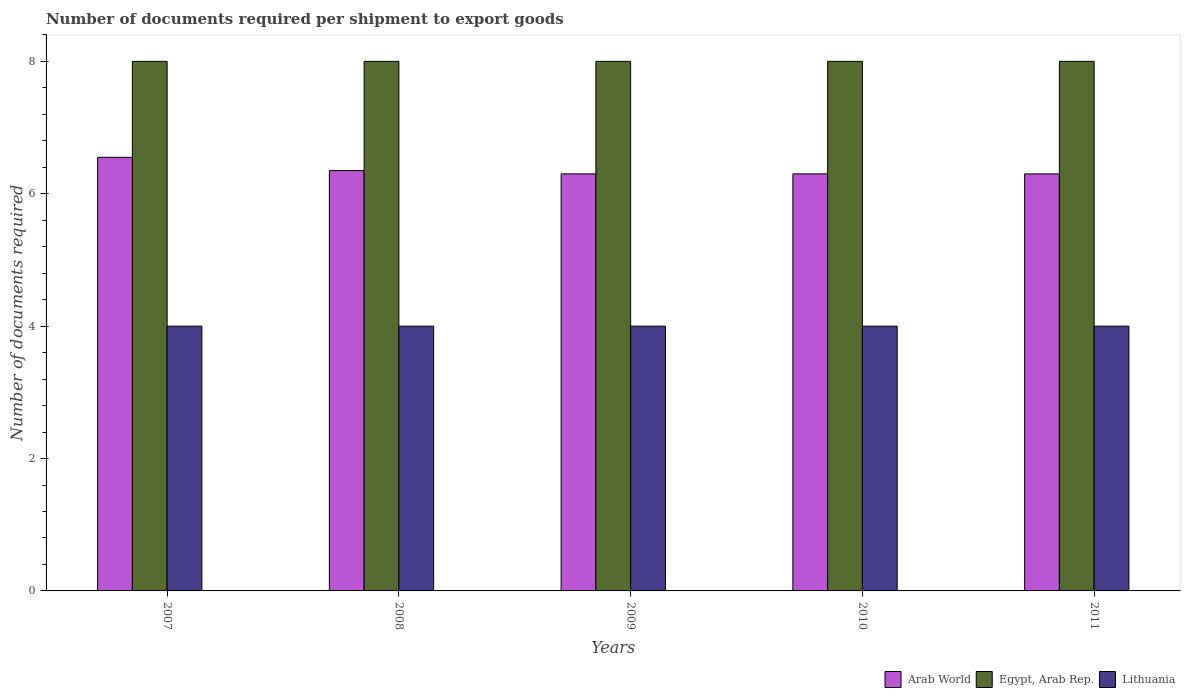How many different coloured bars are there?
Keep it short and to the point. 3. How many groups of bars are there?
Offer a very short reply. 5. Are the number of bars per tick equal to the number of legend labels?
Offer a terse response. Yes. In how many cases, is the number of bars for a given year not equal to the number of legend labels?
Ensure brevity in your answer.  0. Across all years, what is the maximum number of documents required per shipment to export goods in Arab World?
Offer a very short reply. 6.55. Across all years, what is the minimum number of documents required per shipment to export goods in Lithuania?
Provide a succinct answer. 4. What is the total number of documents required per shipment to export goods in Arab World in the graph?
Provide a short and direct response. 31.8. What is the difference between the number of documents required per shipment to export goods in Lithuania in 2007 and the number of documents required per shipment to export goods in Egypt, Arab Rep. in 2010?
Give a very brief answer. -4. What is the average number of documents required per shipment to export goods in Arab World per year?
Provide a succinct answer. 6.36. In the year 2009, what is the difference between the number of documents required per shipment to export goods in Arab World and number of documents required per shipment to export goods in Lithuania?
Offer a terse response. 2.3. Is the difference between the number of documents required per shipment to export goods in Arab World in 2010 and 2011 greater than the difference between the number of documents required per shipment to export goods in Lithuania in 2010 and 2011?
Your answer should be very brief. No. What is the difference between the highest and the second highest number of documents required per shipment to export goods in Egypt, Arab Rep.?
Ensure brevity in your answer.  0. What is the difference between the highest and the lowest number of documents required per shipment to export goods in Lithuania?
Make the answer very short. 0. What does the 2nd bar from the left in 2007 represents?
Keep it short and to the point. Egypt, Arab Rep. What does the 3rd bar from the right in 2011 represents?
Your answer should be very brief. Arab World. Is it the case that in every year, the sum of the number of documents required per shipment to export goods in Egypt, Arab Rep. and number of documents required per shipment to export goods in Lithuania is greater than the number of documents required per shipment to export goods in Arab World?
Your answer should be compact. Yes. Are all the bars in the graph horizontal?
Your response must be concise. No. What is the difference between two consecutive major ticks on the Y-axis?
Provide a short and direct response. 2. Are the values on the major ticks of Y-axis written in scientific E-notation?
Give a very brief answer. No. Where does the legend appear in the graph?
Offer a terse response. Bottom right. What is the title of the graph?
Provide a short and direct response. Number of documents required per shipment to export goods. Does "Guatemala" appear as one of the legend labels in the graph?
Provide a succinct answer. No. What is the label or title of the Y-axis?
Provide a succinct answer. Number of documents required. What is the Number of documents required in Arab World in 2007?
Give a very brief answer. 6.55. What is the Number of documents required of Lithuania in 2007?
Offer a very short reply. 4. What is the Number of documents required in Arab World in 2008?
Provide a short and direct response. 6.35. What is the Number of documents required in Egypt, Arab Rep. in 2008?
Ensure brevity in your answer.  8. What is the Number of documents required of Arab World in 2010?
Your response must be concise. 6.3. What is the Number of documents required in Lithuania in 2010?
Make the answer very short. 4. What is the Number of documents required in Egypt, Arab Rep. in 2011?
Offer a very short reply. 8. What is the Number of documents required of Lithuania in 2011?
Offer a very short reply. 4. Across all years, what is the maximum Number of documents required of Arab World?
Provide a succinct answer. 6.55. Across all years, what is the minimum Number of documents required in Arab World?
Offer a very short reply. 6.3. Across all years, what is the minimum Number of documents required in Egypt, Arab Rep.?
Make the answer very short. 8. Across all years, what is the minimum Number of documents required in Lithuania?
Your answer should be very brief. 4. What is the total Number of documents required of Arab World in the graph?
Your answer should be compact. 31.8. What is the total Number of documents required in Egypt, Arab Rep. in the graph?
Offer a very short reply. 40. What is the total Number of documents required in Lithuania in the graph?
Make the answer very short. 20. What is the difference between the Number of documents required of Arab World in 2007 and that in 2008?
Keep it short and to the point. 0.2. What is the difference between the Number of documents required of Egypt, Arab Rep. in 2007 and that in 2008?
Your response must be concise. 0. What is the difference between the Number of documents required of Egypt, Arab Rep. in 2007 and that in 2009?
Make the answer very short. 0. What is the difference between the Number of documents required in Lithuania in 2007 and that in 2009?
Ensure brevity in your answer.  0. What is the difference between the Number of documents required of Egypt, Arab Rep. in 2007 and that in 2010?
Ensure brevity in your answer.  0. What is the difference between the Number of documents required of Arab World in 2007 and that in 2011?
Make the answer very short. 0.25. What is the difference between the Number of documents required in Egypt, Arab Rep. in 2008 and that in 2009?
Provide a short and direct response. 0. What is the difference between the Number of documents required in Lithuania in 2008 and that in 2009?
Your answer should be very brief. 0. What is the difference between the Number of documents required in Arab World in 2008 and that in 2010?
Your response must be concise. 0.05. What is the difference between the Number of documents required of Lithuania in 2008 and that in 2010?
Make the answer very short. 0. What is the difference between the Number of documents required in Lithuania in 2008 and that in 2011?
Your answer should be compact. 0. What is the difference between the Number of documents required of Egypt, Arab Rep. in 2009 and that in 2010?
Your answer should be very brief. 0. What is the difference between the Number of documents required of Egypt, Arab Rep. in 2009 and that in 2011?
Give a very brief answer. 0. What is the difference between the Number of documents required in Lithuania in 2009 and that in 2011?
Provide a short and direct response. 0. What is the difference between the Number of documents required of Arab World in 2007 and the Number of documents required of Egypt, Arab Rep. in 2008?
Make the answer very short. -1.45. What is the difference between the Number of documents required in Arab World in 2007 and the Number of documents required in Lithuania in 2008?
Make the answer very short. 2.55. What is the difference between the Number of documents required in Arab World in 2007 and the Number of documents required in Egypt, Arab Rep. in 2009?
Provide a succinct answer. -1.45. What is the difference between the Number of documents required of Arab World in 2007 and the Number of documents required of Lithuania in 2009?
Give a very brief answer. 2.55. What is the difference between the Number of documents required of Arab World in 2007 and the Number of documents required of Egypt, Arab Rep. in 2010?
Offer a very short reply. -1.45. What is the difference between the Number of documents required in Arab World in 2007 and the Number of documents required in Lithuania in 2010?
Make the answer very short. 2.55. What is the difference between the Number of documents required of Egypt, Arab Rep. in 2007 and the Number of documents required of Lithuania in 2010?
Offer a terse response. 4. What is the difference between the Number of documents required of Arab World in 2007 and the Number of documents required of Egypt, Arab Rep. in 2011?
Provide a succinct answer. -1.45. What is the difference between the Number of documents required of Arab World in 2007 and the Number of documents required of Lithuania in 2011?
Provide a succinct answer. 2.55. What is the difference between the Number of documents required in Egypt, Arab Rep. in 2007 and the Number of documents required in Lithuania in 2011?
Provide a short and direct response. 4. What is the difference between the Number of documents required in Arab World in 2008 and the Number of documents required in Egypt, Arab Rep. in 2009?
Provide a succinct answer. -1.65. What is the difference between the Number of documents required in Arab World in 2008 and the Number of documents required in Lithuania in 2009?
Keep it short and to the point. 2.35. What is the difference between the Number of documents required of Egypt, Arab Rep. in 2008 and the Number of documents required of Lithuania in 2009?
Your response must be concise. 4. What is the difference between the Number of documents required of Arab World in 2008 and the Number of documents required of Egypt, Arab Rep. in 2010?
Ensure brevity in your answer.  -1.65. What is the difference between the Number of documents required of Arab World in 2008 and the Number of documents required of Lithuania in 2010?
Your answer should be very brief. 2.35. What is the difference between the Number of documents required of Arab World in 2008 and the Number of documents required of Egypt, Arab Rep. in 2011?
Make the answer very short. -1.65. What is the difference between the Number of documents required in Arab World in 2008 and the Number of documents required in Lithuania in 2011?
Give a very brief answer. 2.35. What is the difference between the Number of documents required in Arab World in 2009 and the Number of documents required in Egypt, Arab Rep. in 2010?
Offer a very short reply. -1.7. What is the difference between the Number of documents required of Arab World in 2009 and the Number of documents required of Lithuania in 2010?
Provide a short and direct response. 2.3. What is the difference between the Number of documents required in Arab World in 2009 and the Number of documents required in Egypt, Arab Rep. in 2011?
Give a very brief answer. -1.7. What is the average Number of documents required in Arab World per year?
Give a very brief answer. 6.36. In the year 2007, what is the difference between the Number of documents required in Arab World and Number of documents required in Egypt, Arab Rep.?
Ensure brevity in your answer.  -1.45. In the year 2007, what is the difference between the Number of documents required in Arab World and Number of documents required in Lithuania?
Keep it short and to the point. 2.55. In the year 2007, what is the difference between the Number of documents required of Egypt, Arab Rep. and Number of documents required of Lithuania?
Your answer should be compact. 4. In the year 2008, what is the difference between the Number of documents required of Arab World and Number of documents required of Egypt, Arab Rep.?
Your answer should be very brief. -1.65. In the year 2008, what is the difference between the Number of documents required in Arab World and Number of documents required in Lithuania?
Make the answer very short. 2.35. In the year 2009, what is the difference between the Number of documents required of Arab World and Number of documents required of Lithuania?
Your response must be concise. 2.3. In the year 2009, what is the difference between the Number of documents required of Egypt, Arab Rep. and Number of documents required of Lithuania?
Give a very brief answer. 4. In the year 2010, what is the difference between the Number of documents required of Arab World and Number of documents required of Lithuania?
Your response must be concise. 2.3. In the year 2010, what is the difference between the Number of documents required in Egypt, Arab Rep. and Number of documents required in Lithuania?
Your response must be concise. 4. In the year 2011, what is the difference between the Number of documents required of Arab World and Number of documents required of Egypt, Arab Rep.?
Ensure brevity in your answer.  -1.7. In the year 2011, what is the difference between the Number of documents required in Arab World and Number of documents required in Lithuania?
Your response must be concise. 2.3. What is the ratio of the Number of documents required of Arab World in 2007 to that in 2008?
Give a very brief answer. 1.03. What is the ratio of the Number of documents required of Lithuania in 2007 to that in 2008?
Make the answer very short. 1. What is the ratio of the Number of documents required of Arab World in 2007 to that in 2009?
Your answer should be compact. 1.04. What is the ratio of the Number of documents required of Lithuania in 2007 to that in 2009?
Offer a terse response. 1. What is the ratio of the Number of documents required of Arab World in 2007 to that in 2010?
Offer a very short reply. 1.04. What is the ratio of the Number of documents required in Arab World in 2007 to that in 2011?
Provide a short and direct response. 1.04. What is the ratio of the Number of documents required of Egypt, Arab Rep. in 2007 to that in 2011?
Offer a very short reply. 1. What is the ratio of the Number of documents required of Arab World in 2008 to that in 2009?
Your answer should be very brief. 1.01. What is the ratio of the Number of documents required of Lithuania in 2008 to that in 2009?
Make the answer very short. 1. What is the ratio of the Number of documents required in Arab World in 2008 to that in 2010?
Provide a succinct answer. 1.01. What is the ratio of the Number of documents required in Egypt, Arab Rep. in 2008 to that in 2010?
Give a very brief answer. 1. What is the ratio of the Number of documents required in Lithuania in 2008 to that in 2010?
Your response must be concise. 1. What is the ratio of the Number of documents required of Arab World in 2008 to that in 2011?
Your answer should be compact. 1.01. What is the ratio of the Number of documents required of Egypt, Arab Rep. in 2008 to that in 2011?
Ensure brevity in your answer.  1. What is the ratio of the Number of documents required in Lithuania in 2008 to that in 2011?
Ensure brevity in your answer.  1. What is the ratio of the Number of documents required in Arab World in 2009 to that in 2010?
Provide a succinct answer. 1. What is the ratio of the Number of documents required of Arab World in 2009 to that in 2011?
Give a very brief answer. 1. What is the difference between the highest and the second highest Number of documents required in Egypt, Arab Rep.?
Make the answer very short. 0. What is the difference between the highest and the second highest Number of documents required in Lithuania?
Your answer should be compact. 0. What is the difference between the highest and the lowest Number of documents required in Arab World?
Your answer should be compact. 0.25. What is the difference between the highest and the lowest Number of documents required of Egypt, Arab Rep.?
Keep it short and to the point. 0. What is the difference between the highest and the lowest Number of documents required in Lithuania?
Offer a terse response. 0. 